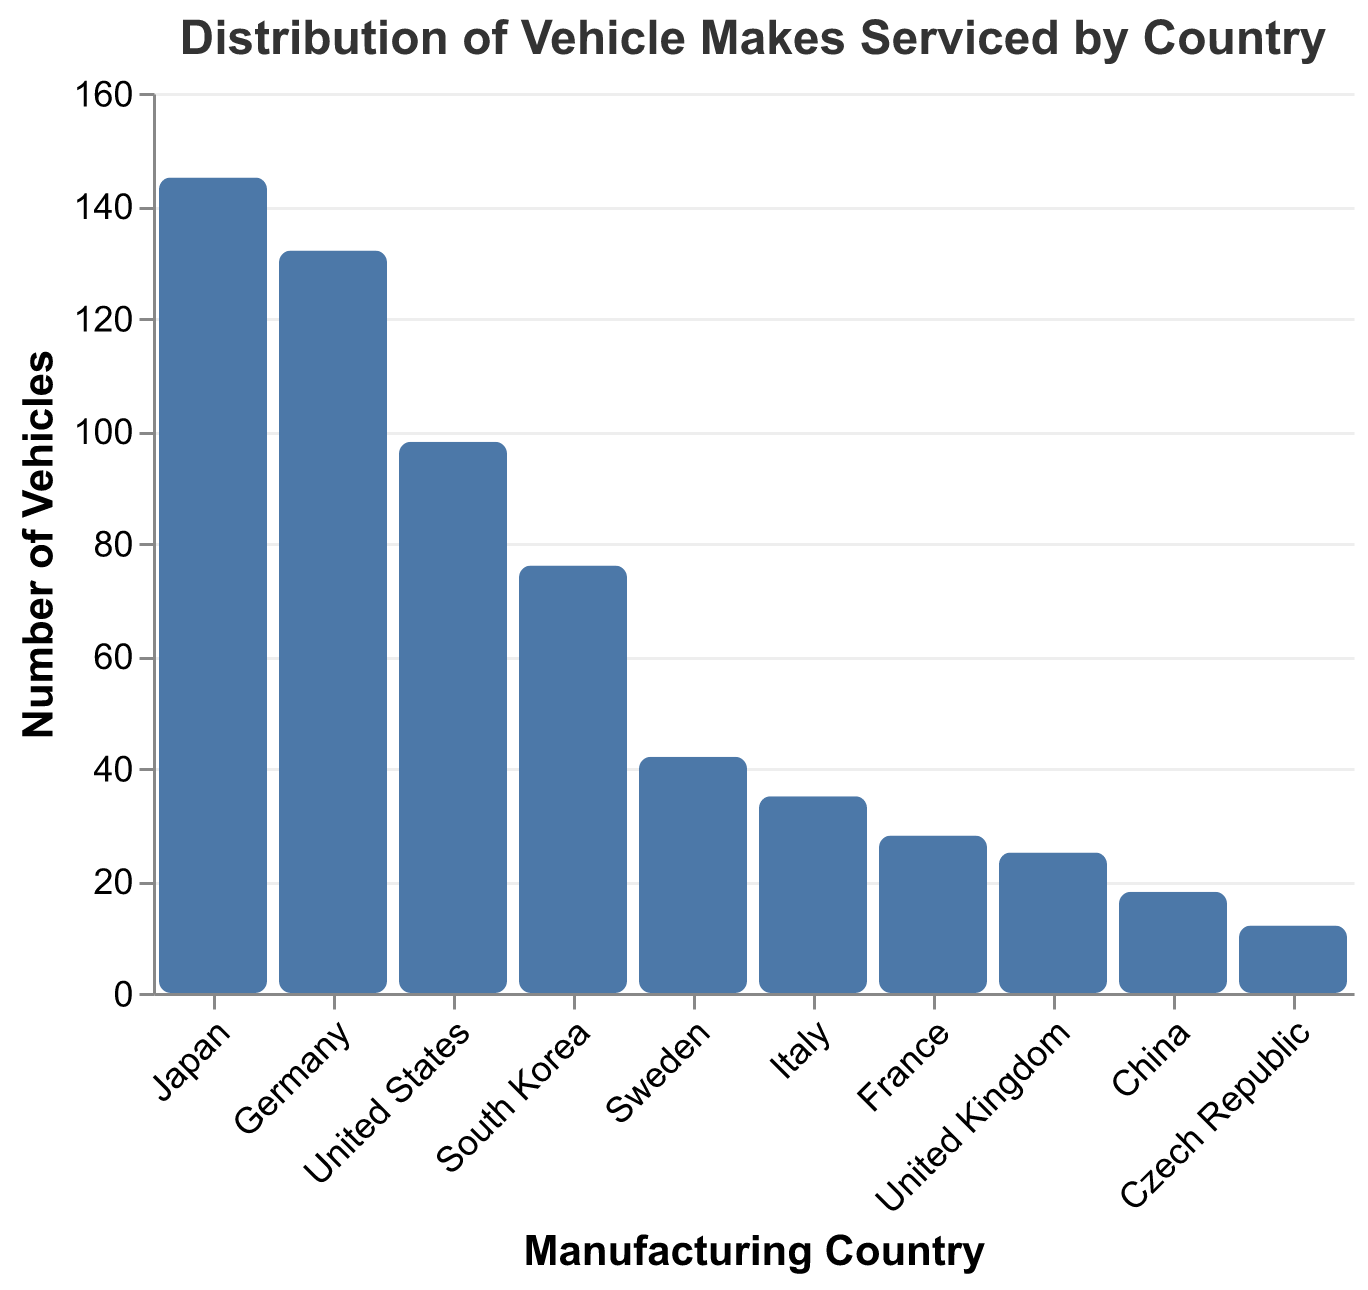What's the title of the figure? The title is typically found at the top of the figure. Here, it is specified in the `title` property of the plot configuration.
Answer: Distribution of Vehicle Makes Serviced by Country Which country has the highest number of vehicles serviced? By looking for the tallest bar in the histogram, we can see that the highest bar corresponds to Japan.
Answer: Japan What is the vehicle count for South Korea? Locate the bar labeled "South Korea" and read off the corresponding height value on the y-axis.
Answer: 76 How many more vehicles were serviced from Japan compared to the United States? Subtract the vehicle count of the United States (98) from that of Japan (145).
Answer: 47 What is the sum of vehicles serviced from Germany and Italy? Add the vehicle counts for Germany (132) and Italy (35).
Answer: 167 Which two countries have the smallest number of vehicles serviced? Find the two shortest bars, which represent Czech Republic and China.
Answer: Czech Republic and China What is the average number of vehicles serviced among the listed countries? Sum all vehicle counts (145 + 132 + 98 + 76 + 42 + 35 + 28 + 25 + 18 + 12 = 611) and divide by the number of countries (10).
Answer: 61.1 Are there more vehicles serviced from Asia (Japan, South Korea, China) or Europe (Germany, Sweden, Italy, France, United Kingdom, Czech Republic)? Sum the vehicle counts for each group and compare: Asia (145 + 76 + 18 = 239) vs. Europe (132 + 42 + 35 + 28 + 25 + 12 = 274).
Answer: Europe Which country has a vehicle count closest to the median value among all countries listed? Arrange the vehicle counts in ascending order: 12, 18, 25, 28, 35, 42, 76, 98, 132, 145. The median is between the 5th and 6th values, both close to 35 (Italy) and 42 (Sweden).
Answer: Italy and Sweden How does the number of vehicles serviced in France compare to that in Sweden? Find the bars for France (28) and Sweden (42) and compare their heights.
Answer: France has fewer than Sweden 